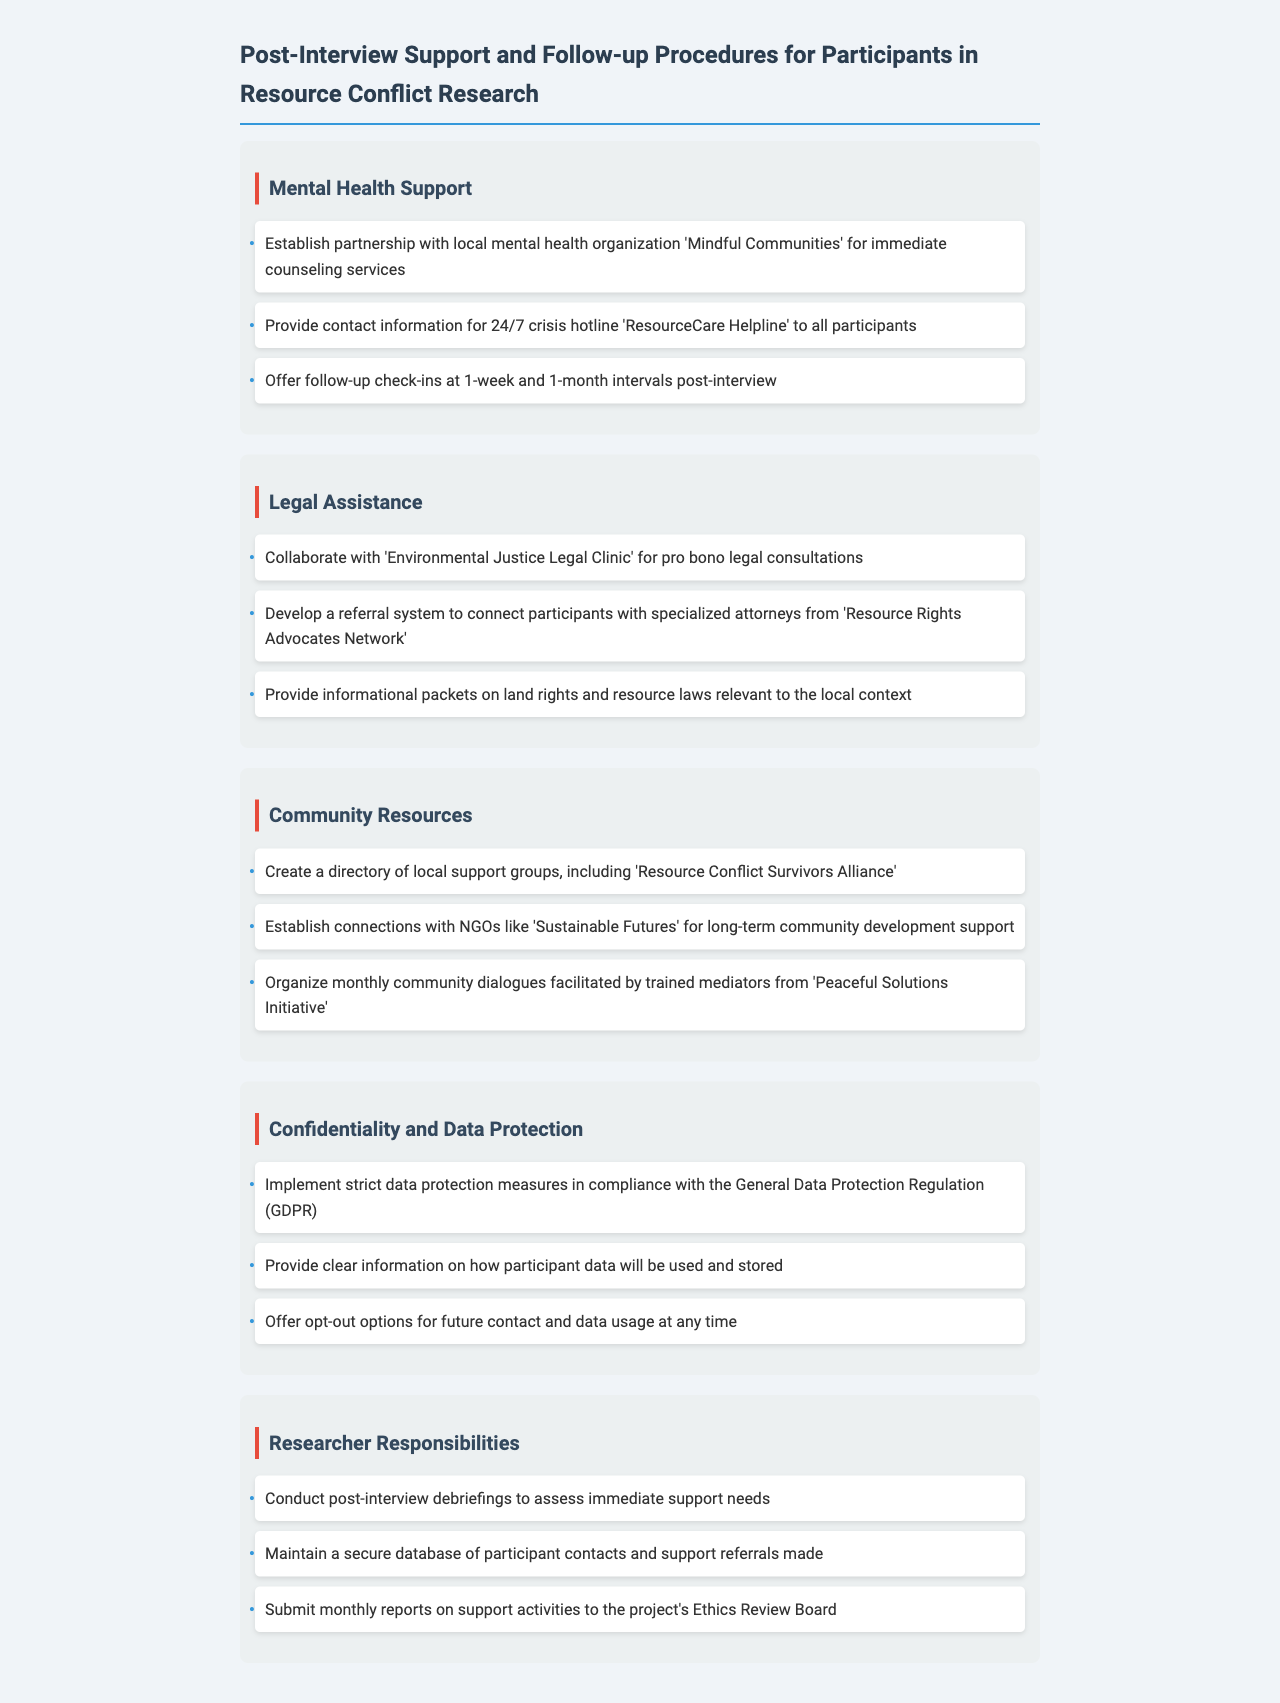What organization is partnered for mental health support? The document indicates a partnership with 'Mindful Communities' for immediate counseling services.
Answer: Mindful Communities What is the name of the crisis hotline provided to participants? The document mentions the 'ResourceCare Helpline' as the 24/7 crisis hotline.
Answer: ResourceCare Helpline How often are follow-up check-ins offered? According to the document, follow-up check-ins are offered at 1-week and 1-month intervals post-interview.
Answer: 1-week and 1-month Which clinic is associated with legal assistance? The document states collaboration with the 'Environmental Justice Legal Clinic' for pro bono legal consultations.
Answer: Environmental Justice Legal Clinic What type of meetings are organized monthly? The document outlines the organization of monthly community dialogues facilitated by trained mediators.
Answer: Community dialogues What is ensured under confidentiality measures? The document states that strict data protection measures are implemented in compliance with the General Data Protection Regulation.
Answer: GDPR What is the purpose of post-interview debriefings? The document mentions conducting post-interview debriefings to assess immediate support needs.
Answer: Assess immediate support needs What type of support is provided by 'Sustainable Futures'? According to the document, 'Sustainable Futures' is connected for long-term community development support.
Answer: Long-term community development support 